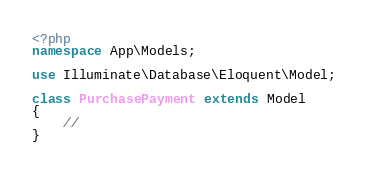<code> <loc_0><loc_0><loc_500><loc_500><_PHP_><?php
namespace App\Models;

use Illuminate\Database\Eloquent\Model;

class PurchasePayment extends Model
{
    //
}
</code> 